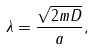Convert formula to latex. <formula><loc_0><loc_0><loc_500><loc_500>\lambda = \frac { \sqrt { 2 m D } } { a } ,</formula> 